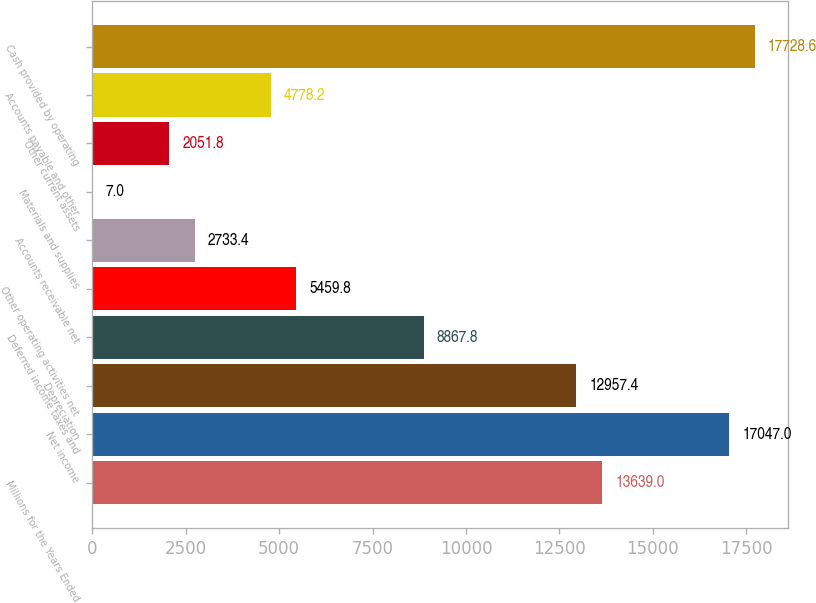Convert chart to OTSL. <chart><loc_0><loc_0><loc_500><loc_500><bar_chart><fcel>Millions for the Years Ended<fcel>Net income<fcel>Depreciation<fcel>Deferred income taxes and<fcel>Other operating activities net<fcel>Accounts receivable net<fcel>Materials and supplies<fcel>Other current assets<fcel>Accounts payable and other<fcel>Cash provided by operating<nl><fcel>13639<fcel>17047<fcel>12957.4<fcel>8867.8<fcel>5459.8<fcel>2733.4<fcel>7<fcel>2051.8<fcel>4778.2<fcel>17728.6<nl></chart> 